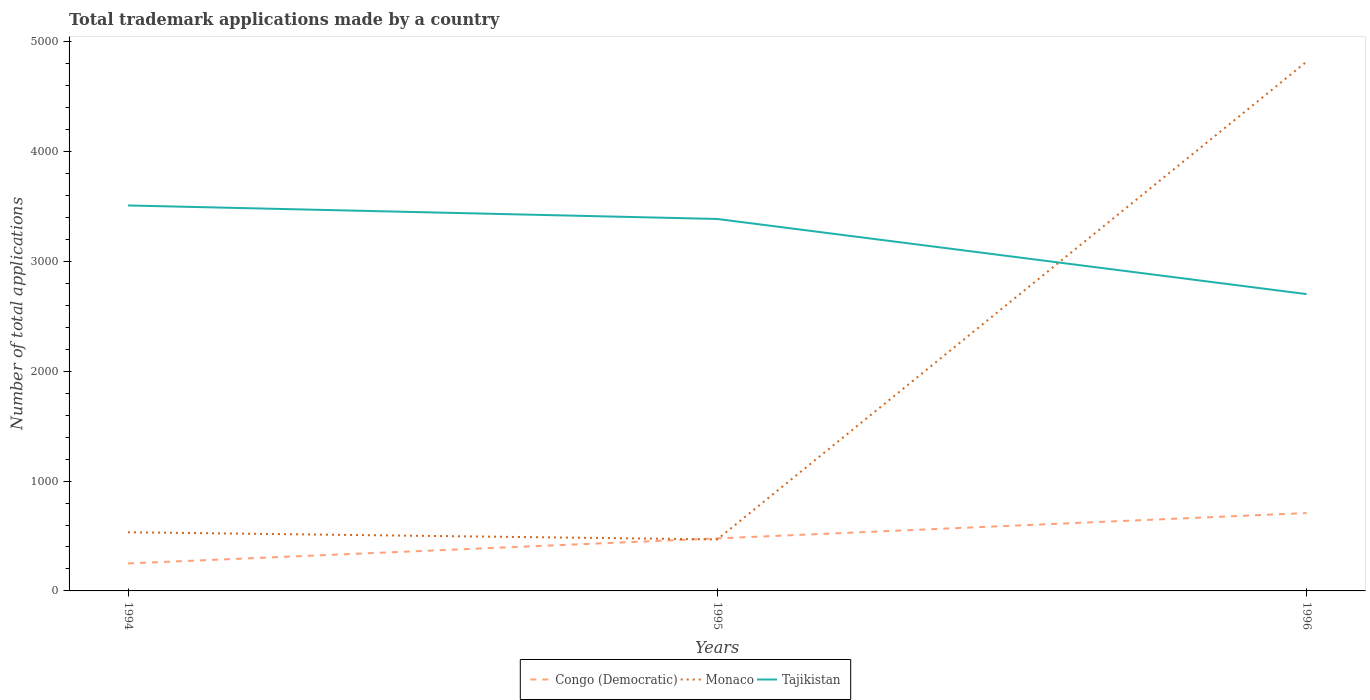How many different coloured lines are there?
Offer a very short reply. 3. Does the line corresponding to Tajikistan intersect with the line corresponding to Monaco?
Provide a short and direct response. Yes. Across all years, what is the maximum number of applications made by in Tajikistan?
Ensure brevity in your answer.  2702. What is the total number of applications made by in Congo (Democratic) in the graph?
Your response must be concise. -459. What is the difference between the highest and the second highest number of applications made by in Monaco?
Offer a very short reply. 4349. What is the difference between the highest and the lowest number of applications made by in Congo (Democratic)?
Offer a very short reply. 1. How many lines are there?
Offer a terse response. 3. What is the difference between two consecutive major ticks on the Y-axis?
Give a very brief answer. 1000. Does the graph contain any zero values?
Offer a terse response. No. Where does the legend appear in the graph?
Offer a very short reply. Bottom center. How many legend labels are there?
Your answer should be compact. 3. What is the title of the graph?
Your answer should be very brief. Total trademark applications made by a country. What is the label or title of the X-axis?
Your answer should be compact. Years. What is the label or title of the Y-axis?
Your answer should be very brief. Number of total applications. What is the Number of total applications of Congo (Democratic) in 1994?
Your response must be concise. 250. What is the Number of total applications of Monaco in 1994?
Your response must be concise. 534. What is the Number of total applications in Tajikistan in 1994?
Offer a terse response. 3509. What is the Number of total applications of Congo (Democratic) in 1995?
Give a very brief answer. 478. What is the Number of total applications in Monaco in 1995?
Ensure brevity in your answer.  469. What is the Number of total applications in Tajikistan in 1995?
Make the answer very short. 3386. What is the Number of total applications in Congo (Democratic) in 1996?
Ensure brevity in your answer.  709. What is the Number of total applications of Monaco in 1996?
Your response must be concise. 4818. What is the Number of total applications in Tajikistan in 1996?
Ensure brevity in your answer.  2702. Across all years, what is the maximum Number of total applications of Congo (Democratic)?
Your answer should be very brief. 709. Across all years, what is the maximum Number of total applications in Monaco?
Your response must be concise. 4818. Across all years, what is the maximum Number of total applications of Tajikistan?
Make the answer very short. 3509. Across all years, what is the minimum Number of total applications in Congo (Democratic)?
Provide a succinct answer. 250. Across all years, what is the minimum Number of total applications in Monaco?
Ensure brevity in your answer.  469. Across all years, what is the minimum Number of total applications in Tajikistan?
Your answer should be compact. 2702. What is the total Number of total applications of Congo (Democratic) in the graph?
Keep it short and to the point. 1437. What is the total Number of total applications of Monaco in the graph?
Ensure brevity in your answer.  5821. What is the total Number of total applications in Tajikistan in the graph?
Give a very brief answer. 9597. What is the difference between the Number of total applications of Congo (Democratic) in 1994 and that in 1995?
Make the answer very short. -228. What is the difference between the Number of total applications of Tajikistan in 1994 and that in 1995?
Provide a short and direct response. 123. What is the difference between the Number of total applications of Congo (Democratic) in 1994 and that in 1996?
Your response must be concise. -459. What is the difference between the Number of total applications of Monaco in 1994 and that in 1996?
Keep it short and to the point. -4284. What is the difference between the Number of total applications in Tajikistan in 1994 and that in 1996?
Ensure brevity in your answer.  807. What is the difference between the Number of total applications of Congo (Democratic) in 1995 and that in 1996?
Offer a terse response. -231. What is the difference between the Number of total applications of Monaco in 1995 and that in 1996?
Your response must be concise. -4349. What is the difference between the Number of total applications of Tajikistan in 1995 and that in 1996?
Offer a very short reply. 684. What is the difference between the Number of total applications in Congo (Democratic) in 1994 and the Number of total applications in Monaco in 1995?
Provide a short and direct response. -219. What is the difference between the Number of total applications of Congo (Democratic) in 1994 and the Number of total applications of Tajikistan in 1995?
Provide a succinct answer. -3136. What is the difference between the Number of total applications in Monaco in 1994 and the Number of total applications in Tajikistan in 1995?
Your answer should be compact. -2852. What is the difference between the Number of total applications of Congo (Democratic) in 1994 and the Number of total applications of Monaco in 1996?
Your response must be concise. -4568. What is the difference between the Number of total applications in Congo (Democratic) in 1994 and the Number of total applications in Tajikistan in 1996?
Offer a terse response. -2452. What is the difference between the Number of total applications in Monaco in 1994 and the Number of total applications in Tajikistan in 1996?
Your response must be concise. -2168. What is the difference between the Number of total applications in Congo (Democratic) in 1995 and the Number of total applications in Monaco in 1996?
Your answer should be very brief. -4340. What is the difference between the Number of total applications in Congo (Democratic) in 1995 and the Number of total applications in Tajikistan in 1996?
Provide a short and direct response. -2224. What is the difference between the Number of total applications in Monaco in 1995 and the Number of total applications in Tajikistan in 1996?
Provide a short and direct response. -2233. What is the average Number of total applications in Congo (Democratic) per year?
Give a very brief answer. 479. What is the average Number of total applications of Monaco per year?
Provide a succinct answer. 1940.33. What is the average Number of total applications in Tajikistan per year?
Offer a very short reply. 3199. In the year 1994, what is the difference between the Number of total applications in Congo (Democratic) and Number of total applications in Monaco?
Give a very brief answer. -284. In the year 1994, what is the difference between the Number of total applications of Congo (Democratic) and Number of total applications of Tajikistan?
Give a very brief answer. -3259. In the year 1994, what is the difference between the Number of total applications in Monaco and Number of total applications in Tajikistan?
Ensure brevity in your answer.  -2975. In the year 1995, what is the difference between the Number of total applications of Congo (Democratic) and Number of total applications of Tajikistan?
Your answer should be compact. -2908. In the year 1995, what is the difference between the Number of total applications in Monaco and Number of total applications in Tajikistan?
Make the answer very short. -2917. In the year 1996, what is the difference between the Number of total applications in Congo (Democratic) and Number of total applications in Monaco?
Provide a succinct answer. -4109. In the year 1996, what is the difference between the Number of total applications of Congo (Democratic) and Number of total applications of Tajikistan?
Your answer should be very brief. -1993. In the year 1996, what is the difference between the Number of total applications in Monaco and Number of total applications in Tajikistan?
Offer a very short reply. 2116. What is the ratio of the Number of total applications in Congo (Democratic) in 1994 to that in 1995?
Your answer should be compact. 0.52. What is the ratio of the Number of total applications in Monaco in 1994 to that in 1995?
Keep it short and to the point. 1.14. What is the ratio of the Number of total applications in Tajikistan in 1994 to that in 1995?
Ensure brevity in your answer.  1.04. What is the ratio of the Number of total applications in Congo (Democratic) in 1994 to that in 1996?
Keep it short and to the point. 0.35. What is the ratio of the Number of total applications in Monaco in 1994 to that in 1996?
Your response must be concise. 0.11. What is the ratio of the Number of total applications of Tajikistan in 1994 to that in 1996?
Ensure brevity in your answer.  1.3. What is the ratio of the Number of total applications of Congo (Democratic) in 1995 to that in 1996?
Offer a terse response. 0.67. What is the ratio of the Number of total applications of Monaco in 1995 to that in 1996?
Offer a terse response. 0.1. What is the ratio of the Number of total applications in Tajikistan in 1995 to that in 1996?
Make the answer very short. 1.25. What is the difference between the highest and the second highest Number of total applications of Congo (Democratic)?
Offer a terse response. 231. What is the difference between the highest and the second highest Number of total applications of Monaco?
Give a very brief answer. 4284. What is the difference between the highest and the second highest Number of total applications in Tajikistan?
Your answer should be compact. 123. What is the difference between the highest and the lowest Number of total applications of Congo (Democratic)?
Keep it short and to the point. 459. What is the difference between the highest and the lowest Number of total applications in Monaco?
Your response must be concise. 4349. What is the difference between the highest and the lowest Number of total applications of Tajikistan?
Your answer should be compact. 807. 